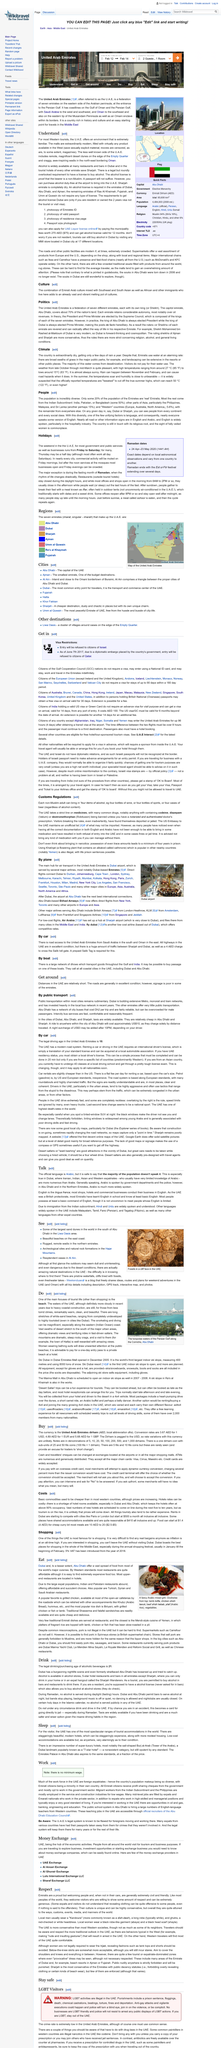Draw attention to some important aspects in this diagram. Khat/qat use is illegal in the UAE, and it is. Yes, it is imperative for readers to understand that the malls in the U.A.E. are extraordinarily modern. When wishing to buy something, the currency used is the United Arab Emirates dirham. It is widely known that the language that the majority of people speak is English. In many major airports and shopping malls, it is possible to exchange cash and travelers' cheques for local currency. These exchanges provide a convenient way to access money while abroad. 